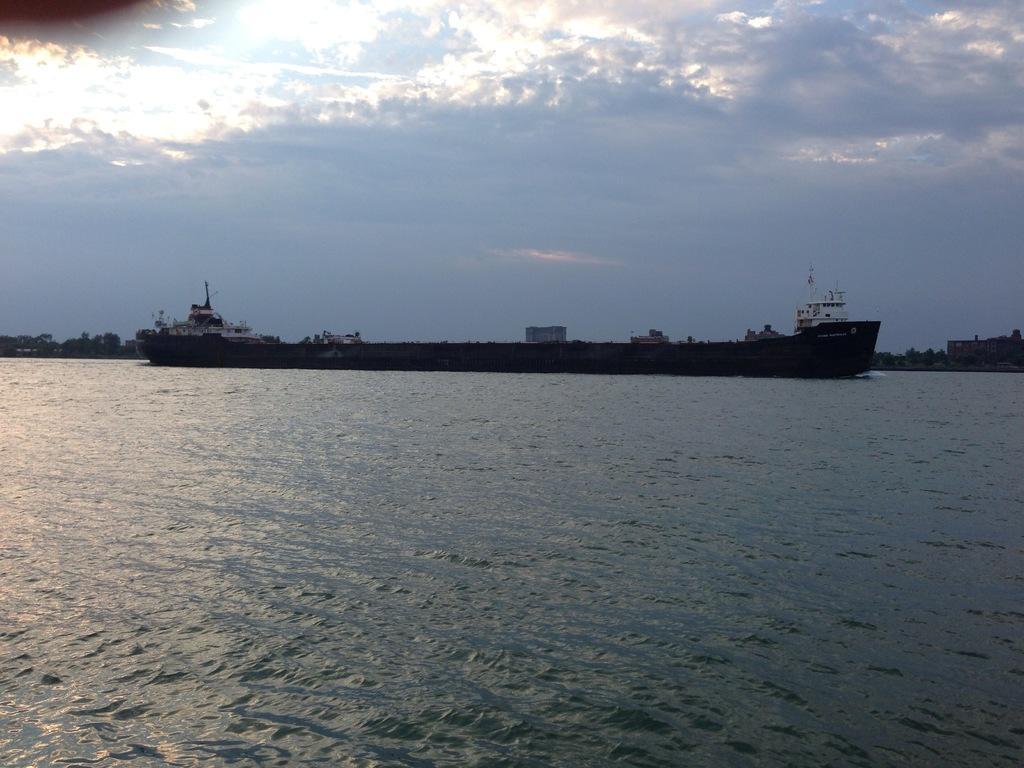In one or two sentences, can you explain what this image depicts? In this picture I can observe a ship floating on the water in the middle of the picture. I can observe a river in this picture. In the background I can observe some clouds in the sky. 